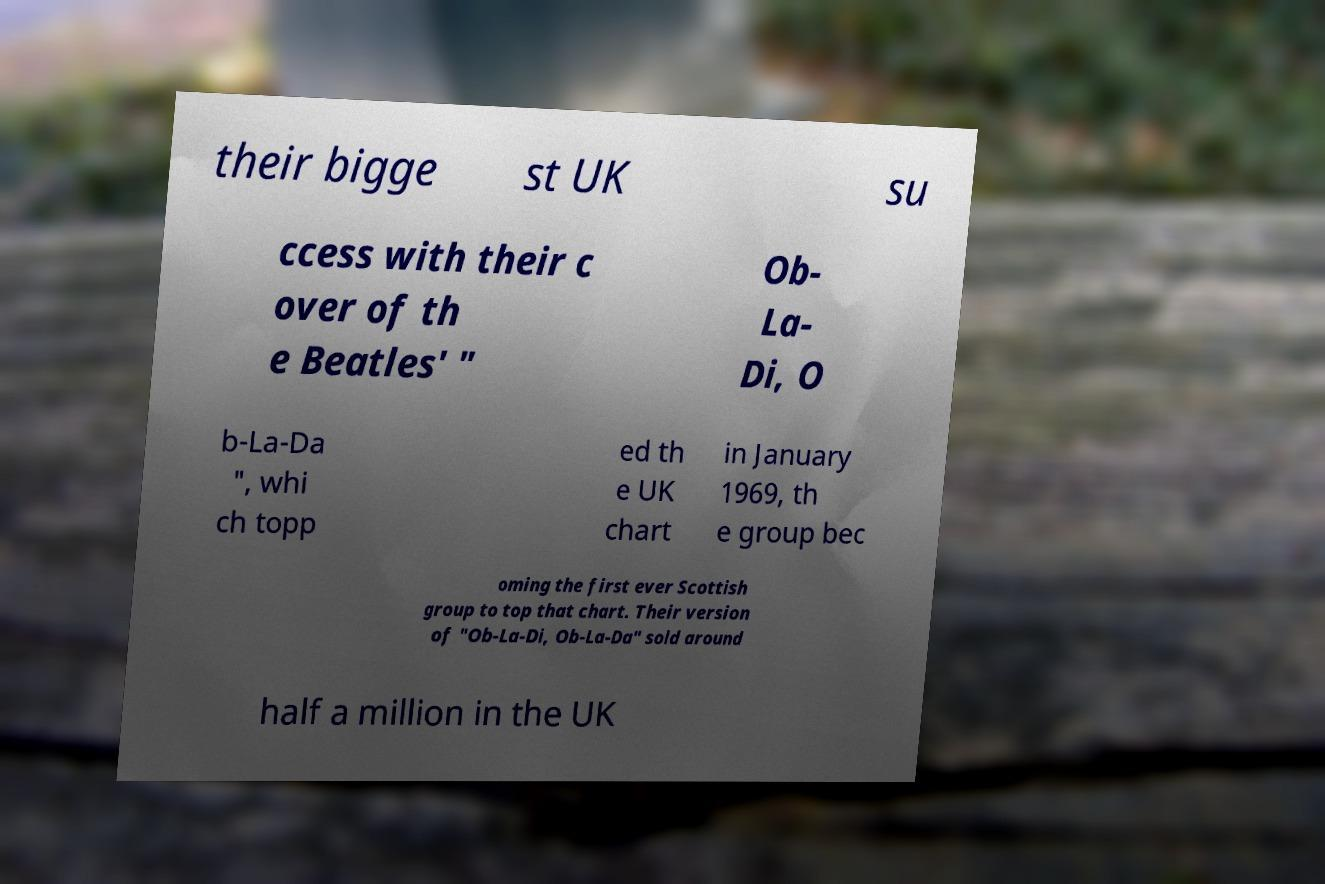Can you accurately transcribe the text from the provided image for me? their bigge st UK su ccess with their c over of th e Beatles' " Ob- La- Di, O b-La-Da ", whi ch topp ed th e UK chart in January 1969, th e group bec oming the first ever Scottish group to top that chart. Their version of "Ob-La-Di, Ob-La-Da" sold around half a million in the UK 